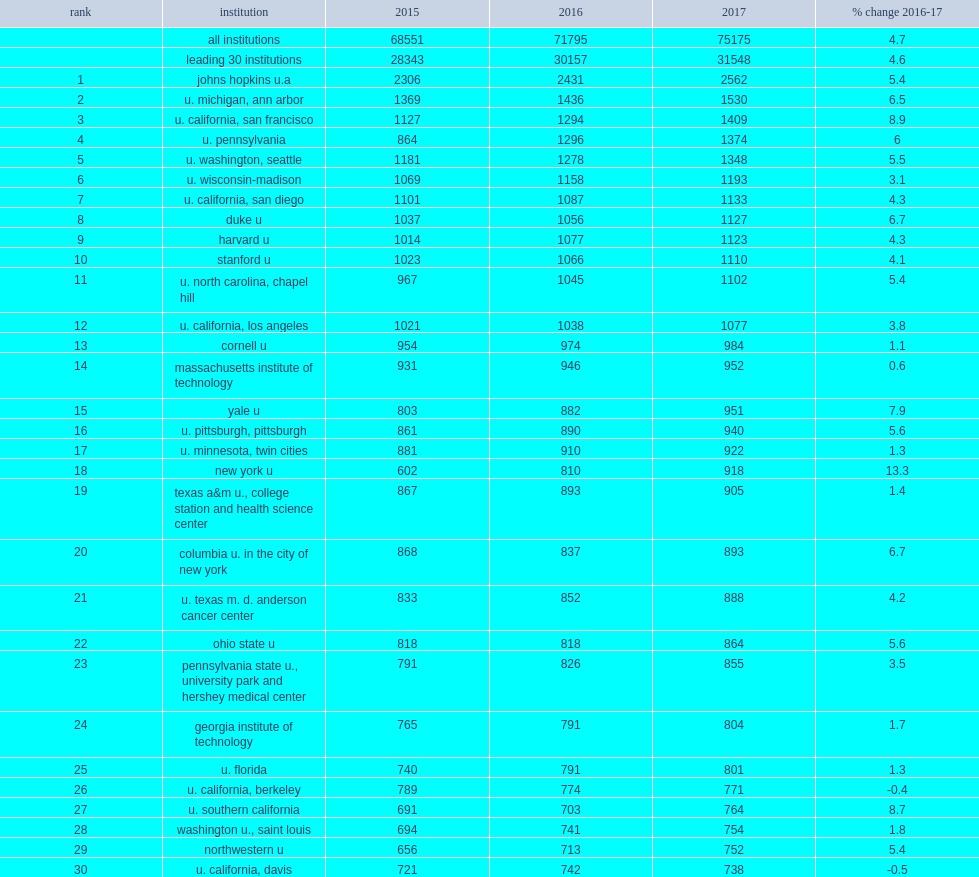How many percent did the top 30 institutions account of the total spent on r&d within the higher education sector in fy 2017? 0.419661. 